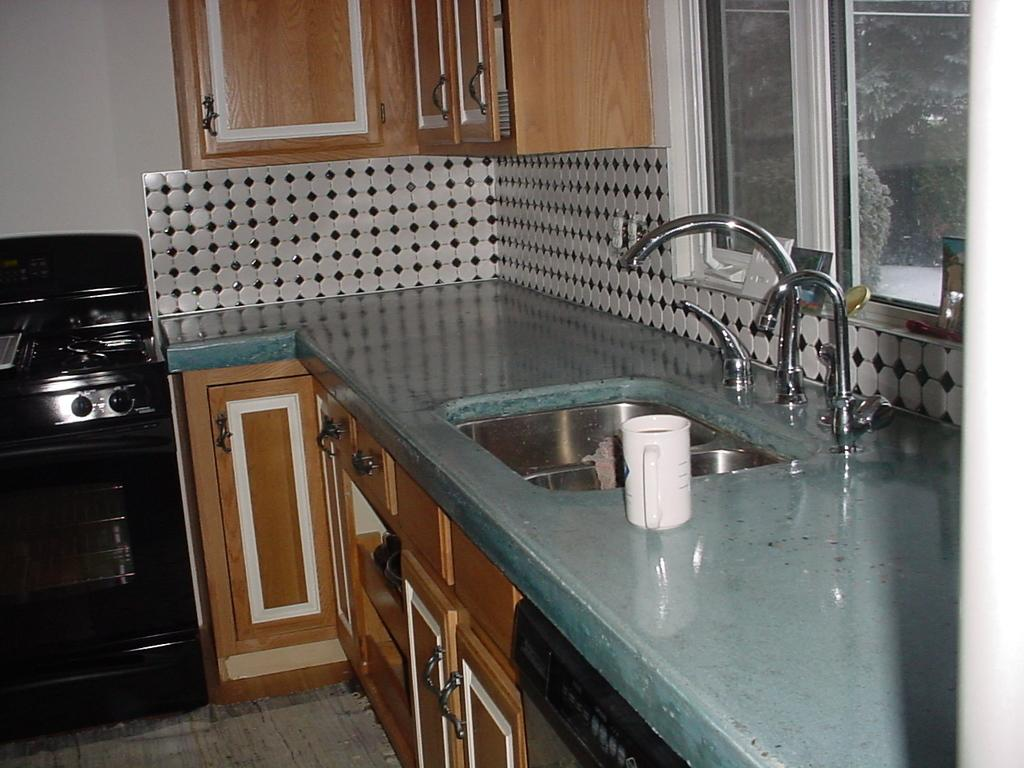What type of fixture is present in the image? There is a sink in the image. How many taps are on the sink? There are three taps on the sink. What type of storage is available in the image? There are cupboards in the image. What can be seen outside the room in the image? There is a window in the image. Who is the writer in the image? There is no writer present in the image. What type of patch is on the cupboard in the image? There is no patch on the cupboard in the image. 